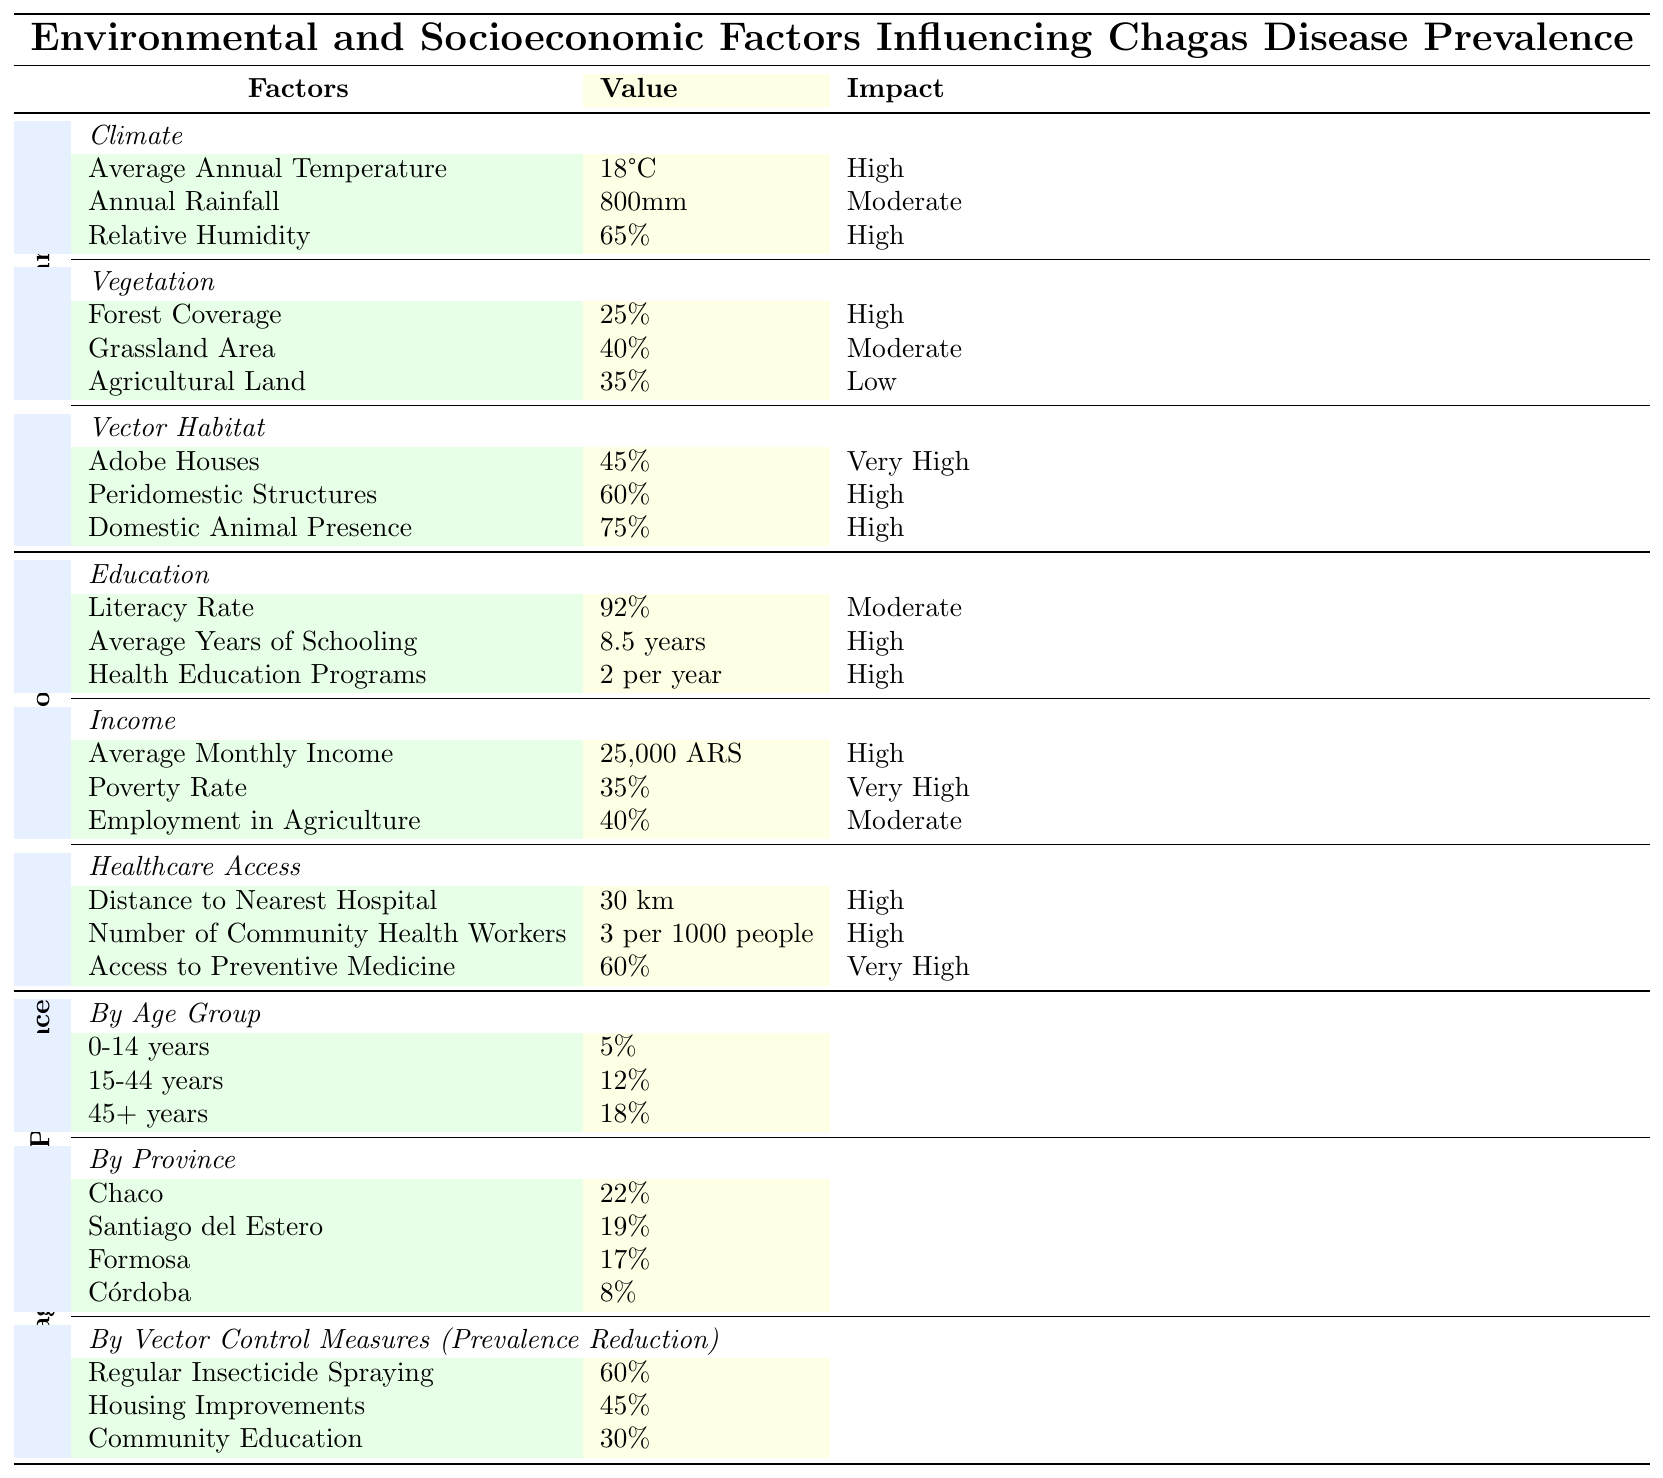What is the impact of the Average Annual Temperature on Chagas disease prevalence? According to the table, the Average Annual Temperature is categorized under environmental factors with an impact labeled as "High."
Answer: High What percentage of households in the region have Adobe Houses? The table lists that 45% of vector habitats consist of Adobe Houses.
Answer: 45% What is the average prevalence of Chagas disease among individuals aged 0-14 and 15-44 years? The prevalence for the age group 0-14 years is 5%, and for 15-44 years, it is 12%. To find the average, we sum the values (5% + 12%) and divide by 2, resulting in (17% / 2) = 8.5%.
Answer: 8.5% In which province is Chagas disease prevalence the highest? By examining the province data, Chaco is listed with the highest prevalence at 22%.
Answer: Chaco What is the total percentage reduction in Chagas disease prevalence from implementing both Regular Insecticide Spraying and Housing Improvements? Regular Insecticide Spraying provides a reduction of 60%, and Housing Improvements offer a 45% reduction. Thus, we simply add these two values (60% + 45%) to find a total reduction of 105%.
Answer: 105% Is the Poverty Rate identified as a low or very high impact factor on Chagas disease prevelance? The Poverty Rate is categorized as "Very High" in the impact section of the income factors.
Answer: Very High What are the two environmental factors with a "High" impact? The two environmental factors marked with a "High" impact are Average Annual Temperature and Relative Humidity.
Answer: Average Annual Temperature and Relative Humidity How does the distance to the nearest hospital correlate with healthcare access categorized by impact? The table indicates that the distance to the nearest hospital has a "High" impact on healthcare access, signifying it plays a significant role in the region's healthcare efficacy.
Answer: High What age group has the highest prevalence of Chagas disease? The age group of 45+ years shows the highest prevalence at 18%.
Answer: 45+ years How many health education programs are conducted per year in the region? The table indicates there are 2 health education programs conducted per year.
Answer: 2 programs per year 